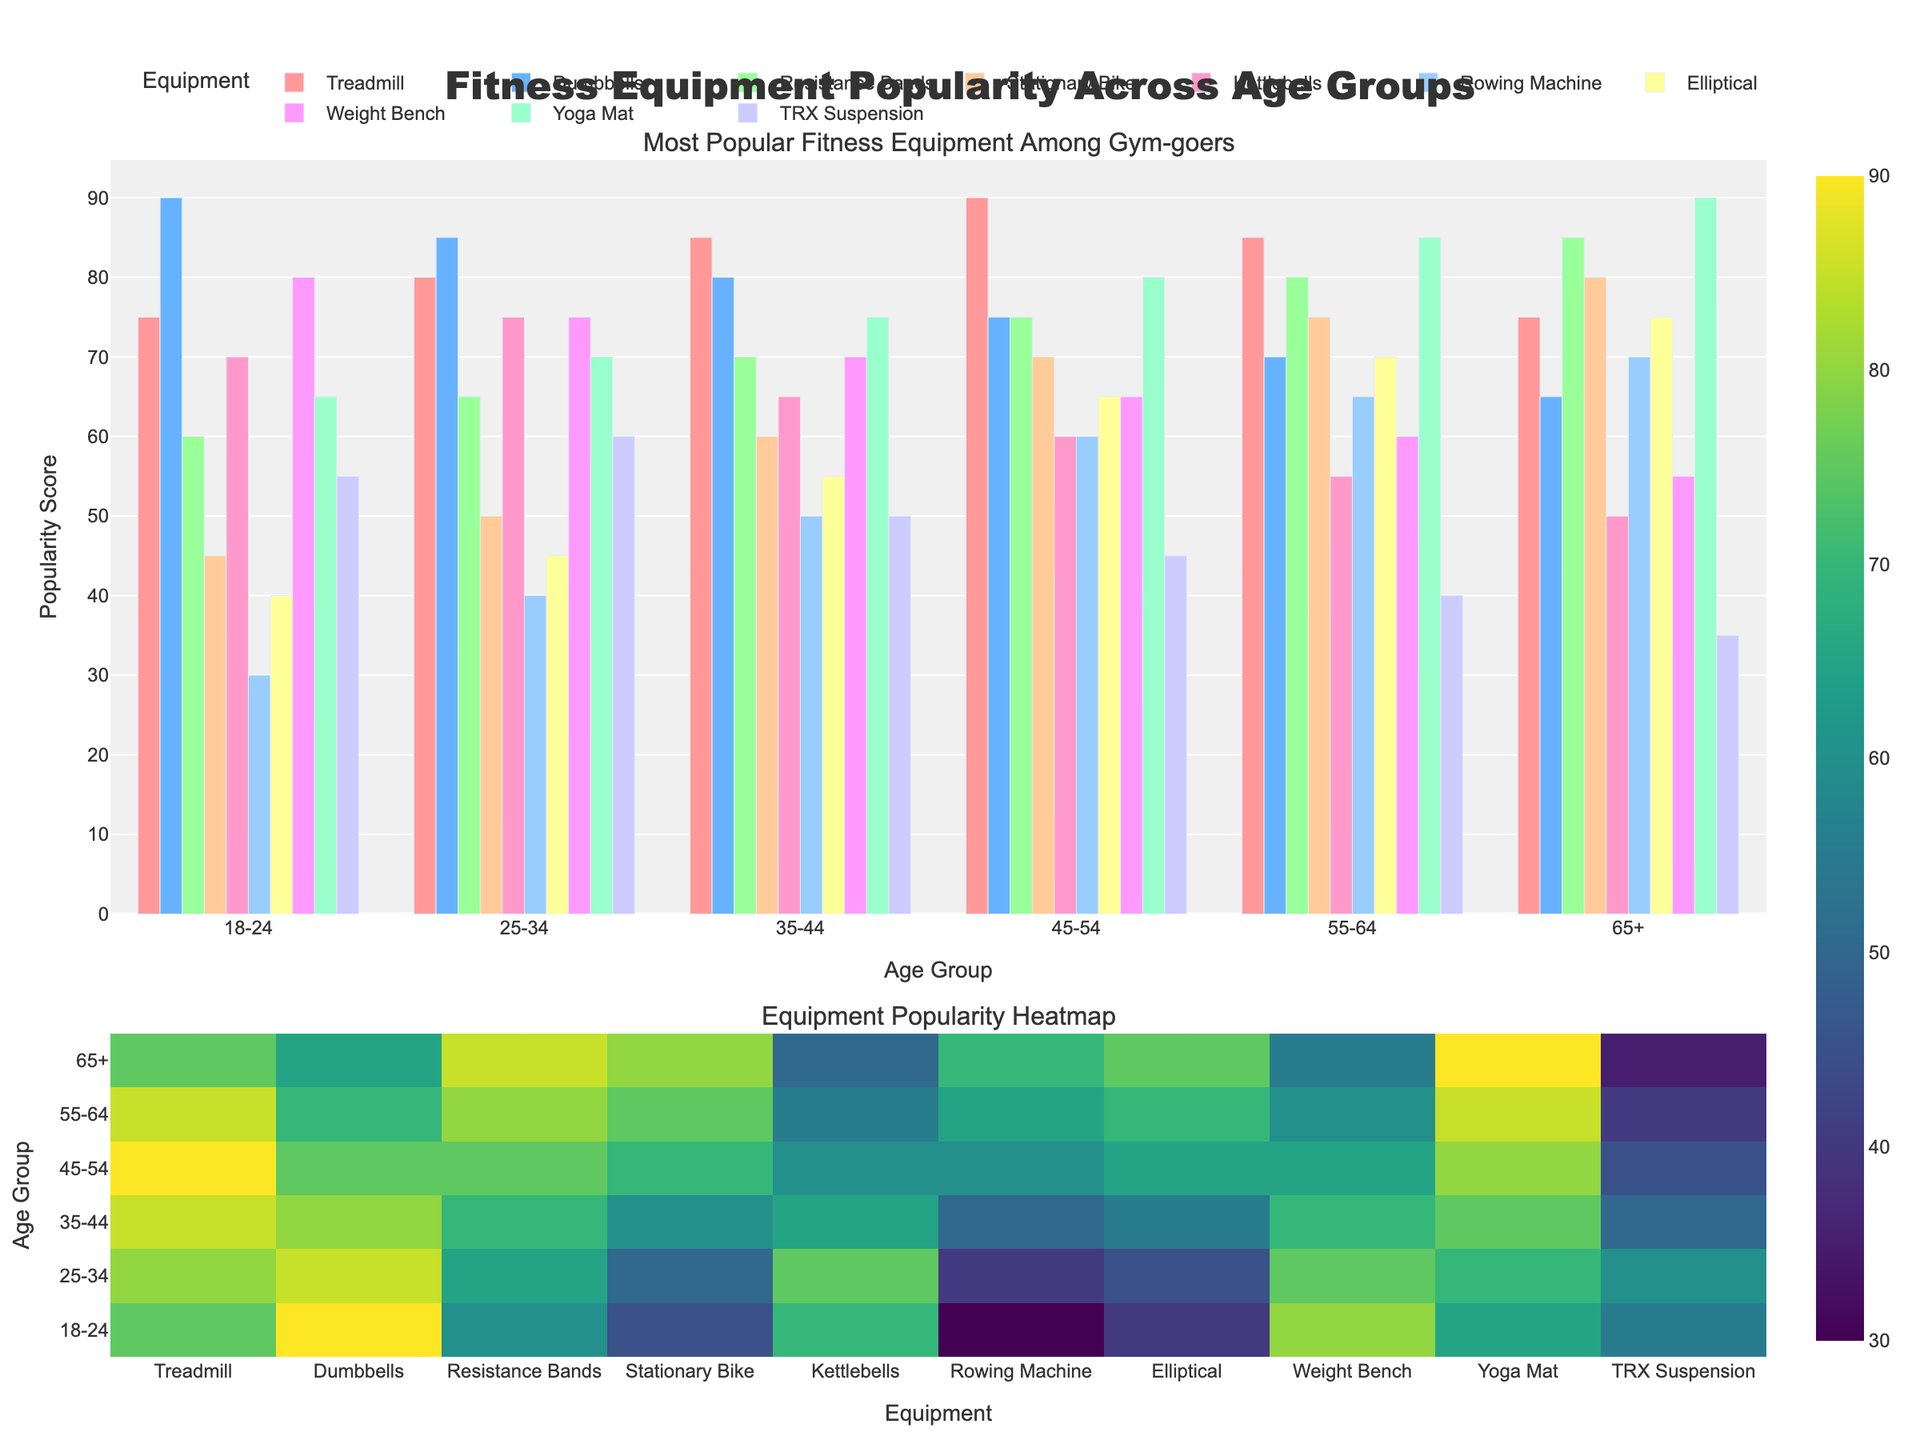Which age group finds Treadmills most popular? By looking at the bar chart or the heatmap, find the age group with the highest bar or heatmap value for Treadmills. In this case, it's the 45-54 age group with a score of 90.
Answer: 45-54 What's the average popularity score of Yoga Mats across all age groups? Sum the popularity scores for Yoga Mats across all age groups: (65 + 70 + 75 + 80 + 85 + 90) = 465. Then divide by the number of age groups, which is 6. So, 465 / 6 = 77.5.
Answer: 77.5 In which age group are Kettlebells and Ellipticals equally popular? Compare the popularity scores for Kettlebells and Ellipticals within each age group until you find an age group where they have the same score. The scores for the 65+ age group both are 75.
Answer: 65+ Which fitness equipment is least popular among the 55-64 age group? By observing the bars or heatmap for the 55-64 age group, find the equipment with the lowest value. For this age group, it is TRX Suspension with a score of 40.
Answer: TRX Suspension What is the difference in popularity score between Dumbbells and Resistance Bands for the 18-24 age group? Find the scores for Dumbbells (90) and Resistance Bands (60) for the 18-24 age group and calculate the difference: 90 - 60 = 30.
Answer: 30 Which equipment has the highest popularity score in the 35-44 age group? Look for the highest bar or the highest value in the heatmap for the 35-44 age group. The highest value in this age group is for Treadmills, with a score of 85.
Answer: Treadmills Which age group shows a higher preference for Stationary Bikes than Dumbbells? Compare the popularity scores for Stationary Bikes and Dumbbells across age groups. The age group where Stationary Bikes have a higher score than Dumbbells is 65+ (80 vs. 65).
Answer: 65+ How many age groups rated Rowing Machines with a popularity score of 60 or higher? Count the number of age groups with Rowing Machine scores of 60 or higher by checking the bars or heatmap. The age groups are 35-44, 45-54, 55-64, and 65+. There are 4 groups.
Answer: 4 Which equipment is most consistently popular across all age groups? Observe which equipment has bars or heatmap values that are the most consistently high and similar across all age groups. Weight Bench tends to have consistently high scores across each age group (55 to 85).
Answer: Weight Bench 